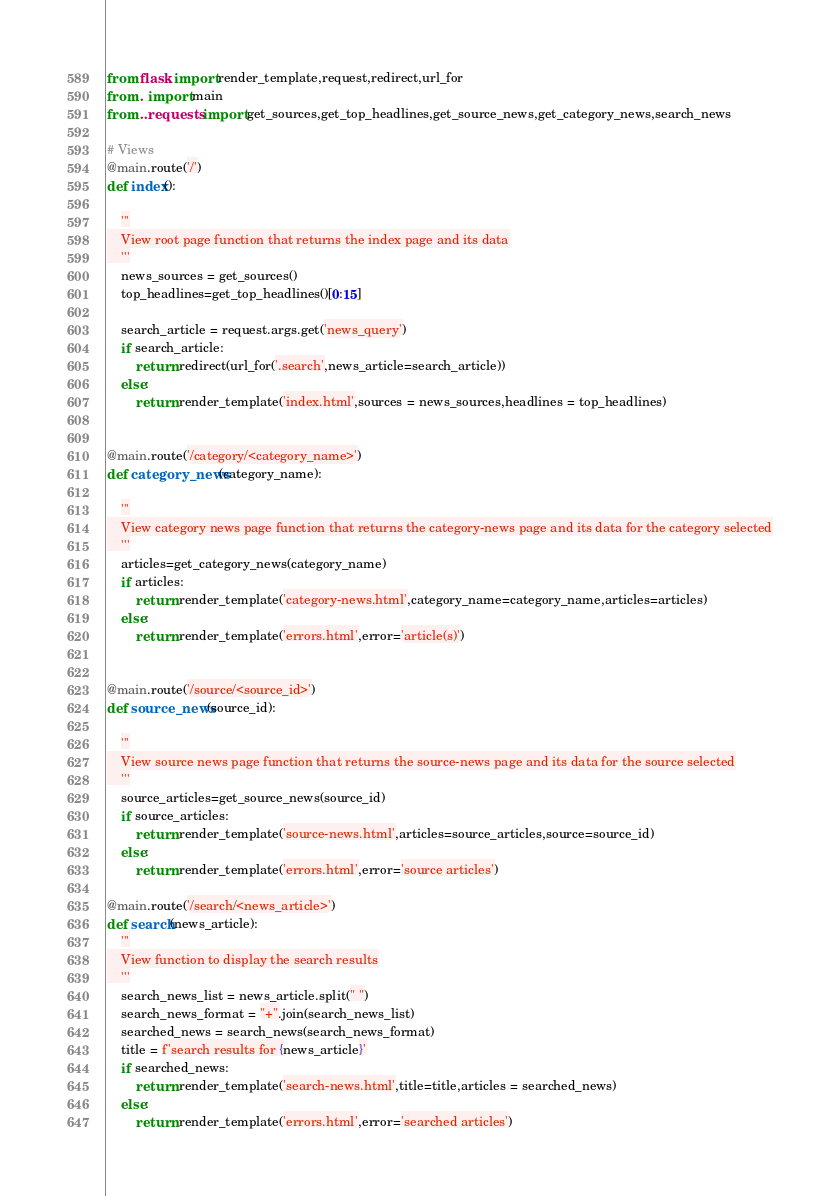<code> <loc_0><loc_0><loc_500><loc_500><_Python_>from flask import render_template,request,redirect,url_for
from . import main
from ..requests import get_sources,get_top_headlines,get_source_news,get_category_news,search_news

# Views
@main.route('/')
def index():

    '''
    View root page function that returns the index page and its data
    '''
    news_sources = get_sources()
    top_headlines=get_top_headlines()[0:15]

    search_article = request.args.get('news_query')
    if search_article:
        return redirect(url_for('.search',news_article=search_article))
    else:    
        return render_template('index.html',sources = news_sources,headlines = top_headlines)


@main.route('/category/<category_name>')
def category_news(category_name):

    '''
    View category news page function that returns the category-news page and its data for the category selected
    '''
    articles=get_category_news(category_name)
    if articles:
        return render_template('category-news.html',category_name=category_name,articles=articles)
    else:
        return render_template('errors.html',error='article(s)')           


@main.route('/source/<source_id>')
def source_news(source_id):

    '''
    View source news page function that returns the source-news page and its data for the source selected
    '''
    source_articles=get_source_news(source_id)
    if source_articles:
        return render_template('source-news.html',articles=source_articles,source=source_id)        
    else:
        return render_template('errors.html',error='source articles')

@main.route('/search/<news_article>')
def search(news_article):
    '''
    View function to display the search results
    '''
    search_news_list = news_article.split(" ")
    search_news_format = "+".join(search_news_list)
    searched_news = search_news(search_news_format)
    title = f'search results for {news_article}'
    if searched_news:
        return render_template('search-news.html',title=title,articles = searched_news)    
    else:
        return render_template('errors.html',error='searched articles')    </code> 